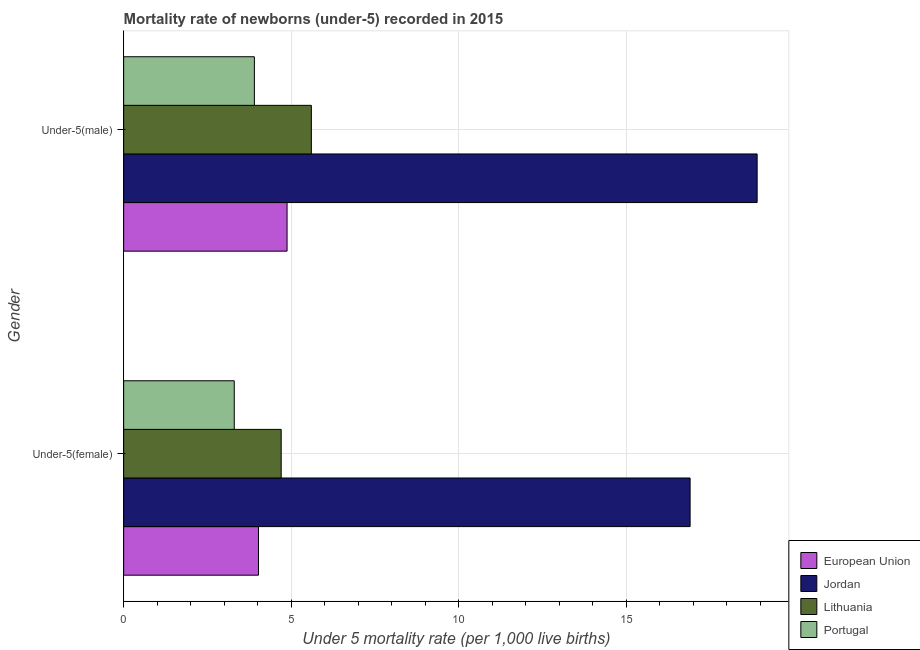How many different coloured bars are there?
Offer a terse response. 4. How many groups of bars are there?
Your answer should be very brief. 2. How many bars are there on the 1st tick from the bottom?
Make the answer very short. 4. What is the label of the 2nd group of bars from the top?
Provide a succinct answer. Under-5(female). In which country was the under-5 female mortality rate maximum?
Provide a short and direct response. Jordan. In which country was the under-5 female mortality rate minimum?
Ensure brevity in your answer.  Portugal. What is the total under-5 female mortality rate in the graph?
Provide a short and direct response. 28.92. What is the difference between the under-5 male mortality rate in Portugal and that in Jordan?
Give a very brief answer. -15. What is the difference between the under-5 male mortality rate in Jordan and the under-5 female mortality rate in Portugal?
Your answer should be very brief. 15.6. What is the average under-5 female mortality rate per country?
Give a very brief answer. 7.23. What is the difference between the under-5 male mortality rate and under-5 female mortality rate in Lithuania?
Your answer should be compact. 0.9. In how many countries, is the under-5 male mortality rate greater than 16 ?
Offer a very short reply. 1. What is the ratio of the under-5 female mortality rate in Portugal to that in Jordan?
Provide a succinct answer. 0.2. What does the 2nd bar from the top in Under-5(male) represents?
Make the answer very short. Lithuania. What does the 3rd bar from the bottom in Under-5(female) represents?
Give a very brief answer. Lithuania. Are all the bars in the graph horizontal?
Provide a short and direct response. Yes. How many countries are there in the graph?
Provide a succinct answer. 4. What is the difference between two consecutive major ticks on the X-axis?
Offer a very short reply. 5. Does the graph contain any zero values?
Provide a short and direct response. No. Does the graph contain grids?
Your answer should be compact. Yes. Where does the legend appear in the graph?
Your answer should be very brief. Bottom right. What is the title of the graph?
Keep it short and to the point. Mortality rate of newborns (under-5) recorded in 2015. What is the label or title of the X-axis?
Offer a very short reply. Under 5 mortality rate (per 1,0 live births). What is the label or title of the Y-axis?
Provide a short and direct response. Gender. What is the Under 5 mortality rate (per 1,000 live births) in European Union in Under-5(female)?
Provide a short and direct response. 4.02. What is the Under 5 mortality rate (per 1,000 live births) of Jordan in Under-5(female)?
Ensure brevity in your answer.  16.9. What is the Under 5 mortality rate (per 1,000 live births) in Portugal in Under-5(female)?
Your answer should be very brief. 3.3. What is the Under 5 mortality rate (per 1,000 live births) in European Union in Under-5(male)?
Offer a terse response. 4.88. What is the Under 5 mortality rate (per 1,000 live births) of Jordan in Under-5(male)?
Provide a short and direct response. 18.9. Across all Gender, what is the maximum Under 5 mortality rate (per 1,000 live births) of European Union?
Provide a succinct answer. 4.88. Across all Gender, what is the minimum Under 5 mortality rate (per 1,000 live births) of European Union?
Your response must be concise. 4.02. Across all Gender, what is the minimum Under 5 mortality rate (per 1,000 live births) of Jordan?
Your answer should be very brief. 16.9. Across all Gender, what is the minimum Under 5 mortality rate (per 1,000 live births) in Portugal?
Keep it short and to the point. 3.3. What is the total Under 5 mortality rate (per 1,000 live births) of European Union in the graph?
Keep it short and to the point. 8.9. What is the total Under 5 mortality rate (per 1,000 live births) of Jordan in the graph?
Your answer should be compact. 35.8. What is the difference between the Under 5 mortality rate (per 1,000 live births) of European Union in Under-5(female) and that in Under-5(male)?
Your response must be concise. -0.85. What is the difference between the Under 5 mortality rate (per 1,000 live births) in Portugal in Under-5(female) and that in Under-5(male)?
Provide a short and direct response. -0.6. What is the difference between the Under 5 mortality rate (per 1,000 live births) in European Union in Under-5(female) and the Under 5 mortality rate (per 1,000 live births) in Jordan in Under-5(male)?
Provide a short and direct response. -14.88. What is the difference between the Under 5 mortality rate (per 1,000 live births) of European Union in Under-5(female) and the Under 5 mortality rate (per 1,000 live births) of Lithuania in Under-5(male)?
Keep it short and to the point. -1.58. What is the difference between the Under 5 mortality rate (per 1,000 live births) in European Union in Under-5(female) and the Under 5 mortality rate (per 1,000 live births) in Portugal in Under-5(male)?
Your answer should be compact. 0.12. What is the average Under 5 mortality rate (per 1,000 live births) of European Union per Gender?
Your response must be concise. 4.45. What is the average Under 5 mortality rate (per 1,000 live births) of Lithuania per Gender?
Ensure brevity in your answer.  5.15. What is the average Under 5 mortality rate (per 1,000 live births) of Portugal per Gender?
Make the answer very short. 3.6. What is the difference between the Under 5 mortality rate (per 1,000 live births) of European Union and Under 5 mortality rate (per 1,000 live births) of Jordan in Under-5(female)?
Your answer should be compact. -12.88. What is the difference between the Under 5 mortality rate (per 1,000 live births) of European Union and Under 5 mortality rate (per 1,000 live births) of Lithuania in Under-5(female)?
Ensure brevity in your answer.  -0.68. What is the difference between the Under 5 mortality rate (per 1,000 live births) of European Union and Under 5 mortality rate (per 1,000 live births) of Portugal in Under-5(female)?
Provide a short and direct response. 0.72. What is the difference between the Under 5 mortality rate (per 1,000 live births) in Lithuania and Under 5 mortality rate (per 1,000 live births) in Portugal in Under-5(female)?
Give a very brief answer. 1.4. What is the difference between the Under 5 mortality rate (per 1,000 live births) in European Union and Under 5 mortality rate (per 1,000 live births) in Jordan in Under-5(male)?
Provide a short and direct response. -14.02. What is the difference between the Under 5 mortality rate (per 1,000 live births) in European Union and Under 5 mortality rate (per 1,000 live births) in Lithuania in Under-5(male)?
Offer a terse response. -0.72. What is the difference between the Under 5 mortality rate (per 1,000 live births) of European Union and Under 5 mortality rate (per 1,000 live births) of Portugal in Under-5(male)?
Ensure brevity in your answer.  0.98. What is the ratio of the Under 5 mortality rate (per 1,000 live births) in European Union in Under-5(female) to that in Under-5(male)?
Keep it short and to the point. 0.82. What is the ratio of the Under 5 mortality rate (per 1,000 live births) of Jordan in Under-5(female) to that in Under-5(male)?
Provide a short and direct response. 0.89. What is the ratio of the Under 5 mortality rate (per 1,000 live births) of Lithuania in Under-5(female) to that in Under-5(male)?
Provide a succinct answer. 0.84. What is the ratio of the Under 5 mortality rate (per 1,000 live births) of Portugal in Under-5(female) to that in Under-5(male)?
Give a very brief answer. 0.85. What is the difference between the highest and the second highest Under 5 mortality rate (per 1,000 live births) in European Union?
Offer a very short reply. 0.85. What is the difference between the highest and the second highest Under 5 mortality rate (per 1,000 live births) of Jordan?
Make the answer very short. 2. What is the difference between the highest and the lowest Under 5 mortality rate (per 1,000 live births) in European Union?
Your answer should be compact. 0.85. 